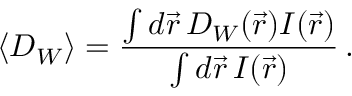Convert formula to latex. <formula><loc_0><loc_0><loc_500><loc_500>\langle D _ { W } \rangle = \frac { \int d \vec { r } \, D _ { W } ( \vec { r } ) I ( \vec { r } ) } { \int d \vec { r } \, I ( \vec { r } ) } \, .</formula> 